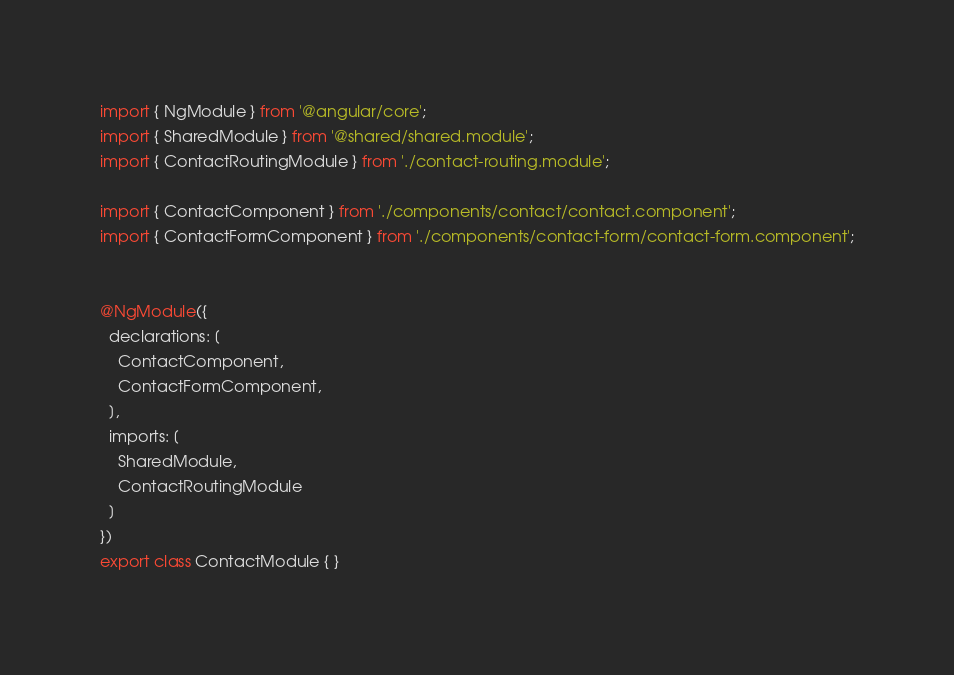<code> <loc_0><loc_0><loc_500><loc_500><_TypeScript_>import { NgModule } from '@angular/core';
import { SharedModule } from '@shared/shared.module';
import { ContactRoutingModule } from './contact-routing.module';

import { ContactComponent } from './components/contact/contact.component';
import { ContactFormComponent } from './components/contact-form/contact-form.component';


@NgModule({
  declarations: [
    ContactComponent,
    ContactFormComponent,
  ],
  imports: [
    SharedModule,
    ContactRoutingModule
  ]
})
export class ContactModule { }
</code> 